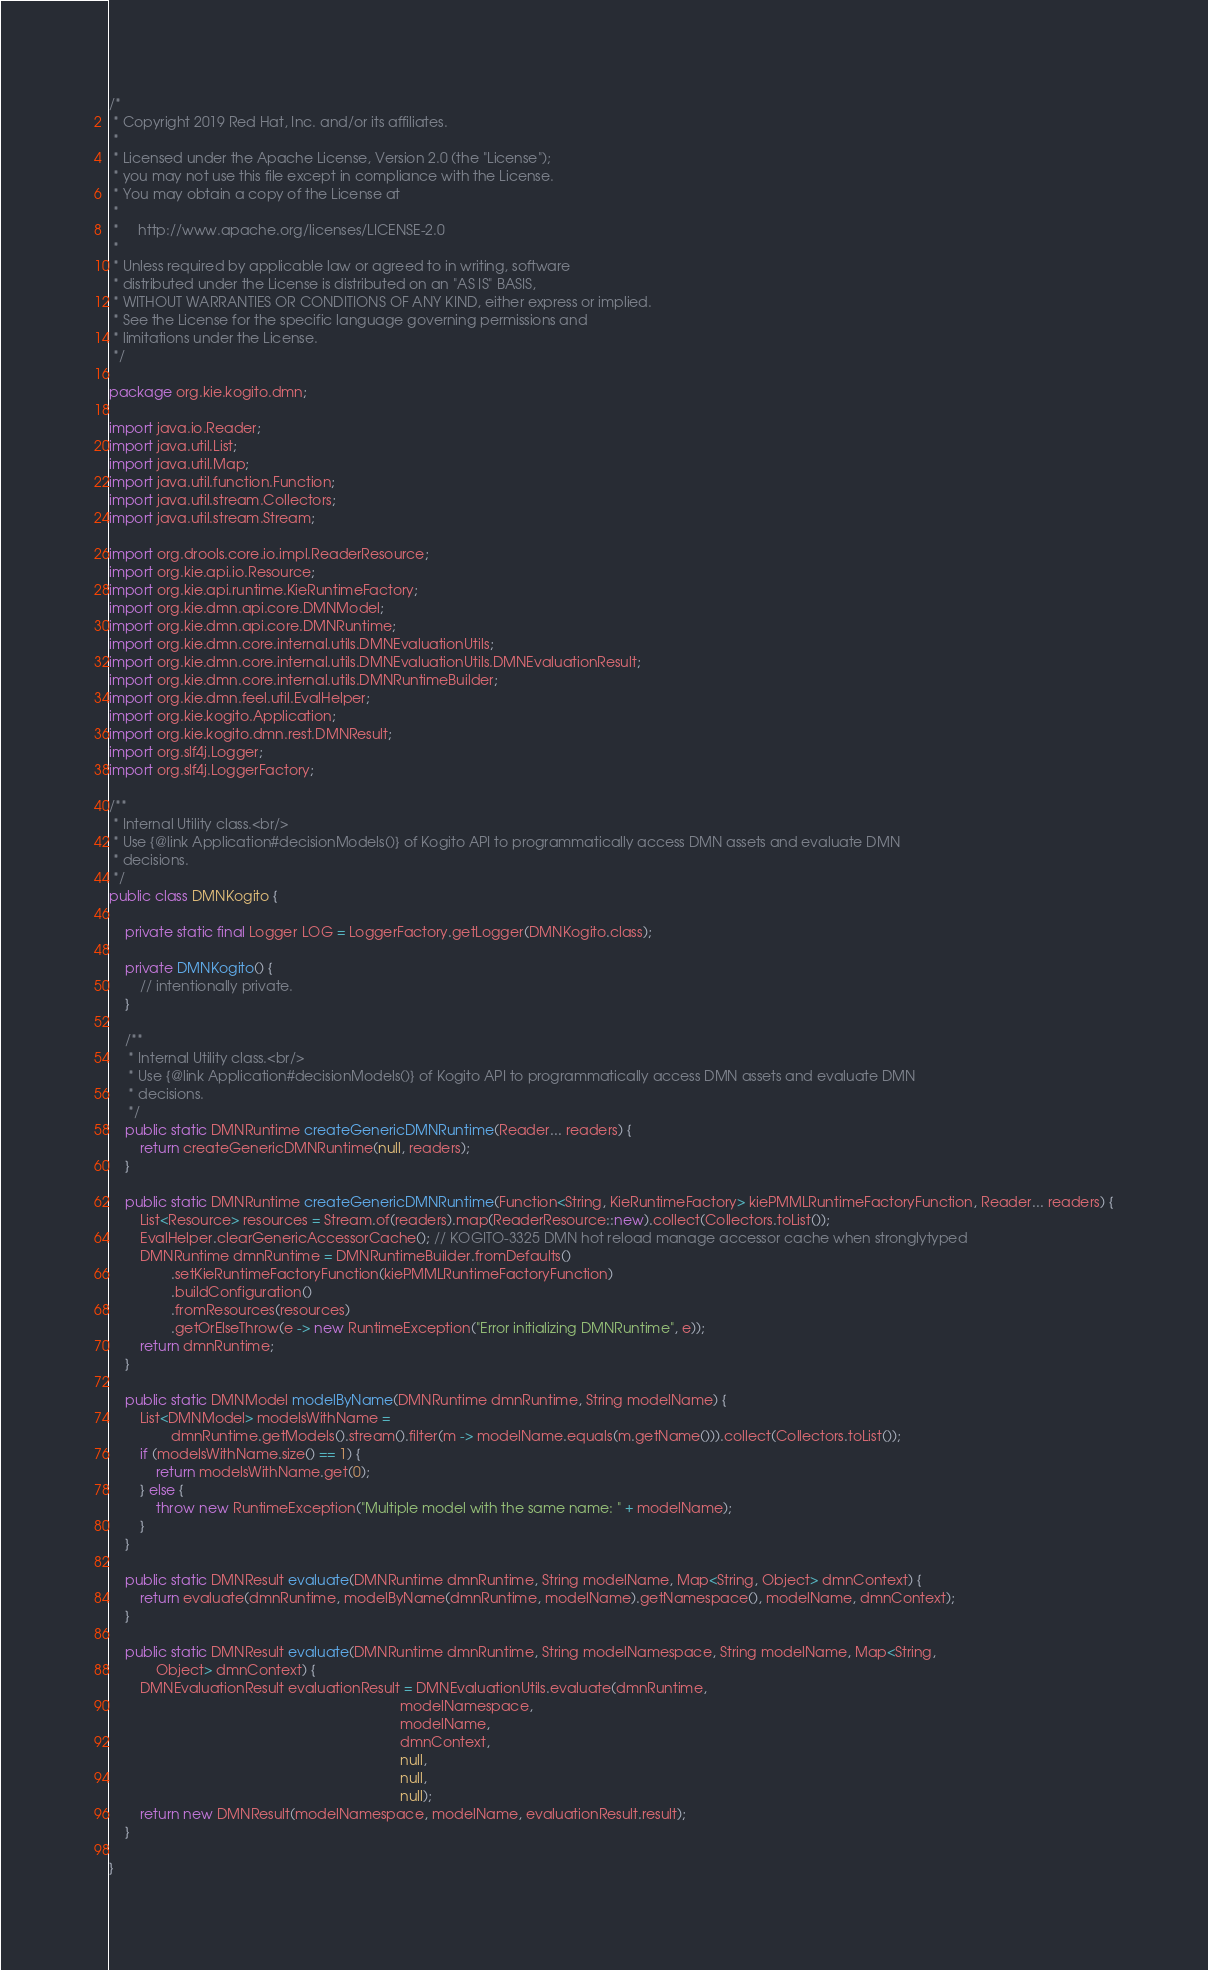<code> <loc_0><loc_0><loc_500><loc_500><_Java_>/*
 * Copyright 2019 Red Hat, Inc. and/or its affiliates.
 *
 * Licensed under the Apache License, Version 2.0 (the "License");
 * you may not use this file except in compliance with the License.
 * You may obtain a copy of the License at
 *
 *     http://www.apache.org/licenses/LICENSE-2.0
 *
 * Unless required by applicable law or agreed to in writing, software
 * distributed under the License is distributed on an "AS IS" BASIS,
 * WITHOUT WARRANTIES OR CONDITIONS OF ANY KIND, either express or implied.
 * See the License for the specific language governing permissions and
 * limitations under the License.
 */

package org.kie.kogito.dmn;

import java.io.Reader;
import java.util.List;
import java.util.Map;
import java.util.function.Function;
import java.util.stream.Collectors;
import java.util.stream.Stream;

import org.drools.core.io.impl.ReaderResource;
import org.kie.api.io.Resource;
import org.kie.api.runtime.KieRuntimeFactory;
import org.kie.dmn.api.core.DMNModel;
import org.kie.dmn.api.core.DMNRuntime;
import org.kie.dmn.core.internal.utils.DMNEvaluationUtils;
import org.kie.dmn.core.internal.utils.DMNEvaluationUtils.DMNEvaluationResult;
import org.kie.dmn.core.internal.utils.DMNRuntimeBuilder;
import org.kie.dmn.feel.util.EvalHelper;
import org.kie.kogito.Application;
import org.kie.kogito.dmn.rest.DMNResult;
import org.slf4j.Logger;
import org.slf4j.LoggerFactory;

/**
 * Internal Utility class.<br/>
 * Use {@link Application#decisionModels()} of Kogito API to programmatically access DMN assets and evaluate DMN
 * decisions.
 */
public class DMNKogito {

    private static final Logger LOG = LoggerFactory.getLogger(DMNKogito.class);

    private DMNKogito() {
        // intentionally private.
    }

    /**
     * Internal Utility class.<br/>
     * Use {@link Application#decisionModels()} of Kogito API to programmatically access DMN assets and evaluate DMN
     * decisions.
     */
    public static DMNRuntime createGenericDMNRuntime(Reader... readers) {
        return createGenericDMNRuntime(null, readers);
    }

    public static DMNRuntime createGenericDMNRuntime(Function<String, KieRuntimeFactory> kiePMMLRuntimeFactoryFunction, Reader... readers) {
        List<Resource> resources = Stream.of(readers).map(ReaderResource::new).collect(Collectors.toList());
        EvalHelper.clearGenericAccessorCache(); // KOGITO-3325 DMN hot reload manage accessor cache when stronglytyped
        DMNRuntime dmnRuntime = DMNRuntimeBuilder.fromDefaults()
                .setKieRuntimeFactoryFunction(kiePMMLRuntimeFactoryFunction)
                .buildConfiguration()
                .fromResources(resources)
                .getOrElseThrow(e -> new RuntimeException("Error initializing DMNRuntime", e));
        return dmnRuntime;
    }

    public static DMNModel modelByName(DMNRuntime dmnRuntime, String modelName) {
        List<DMNModel> modelsWithName =
                dmnRuntime.getModels().stream().filter(m -> modelName.equals(m.getName())).collect(Collectors.toList());
        if (modelsWithName.size() == 1) {
            return modelsWithName.get(0);
        } else {
            throw new RuntimeException("Multiple model with the same name: " + modelName);
        }
    }

    public static DMNResult evaluate(DMNRuntime dmnRuntime, String modelName, Map<String, Object> dmnContext) {
        return evaluate(dmnRuntime, modelByName(dmnRuntime, modelName).getNamespace(), modelName, dmnContext);
    }

    public static DMNResult evaluate(DMNRuntime dmnRuntime, String modelNamespace, String modelName, Map<String,
            Object> dmnContext) {
        DMNEvaluationResult evaluationResult = DMNEvaluationUtils.evaluate(dmnRuntime,
                                                                           modelNamespace,
                                                                           modelName,
                                                                           dmnContext,
                                                                           null,
                                                                           null,
                                                                           null);
        return new DMNResult(modelNamespace, modelName, evaluationResult.result);
    }

}
</code> 